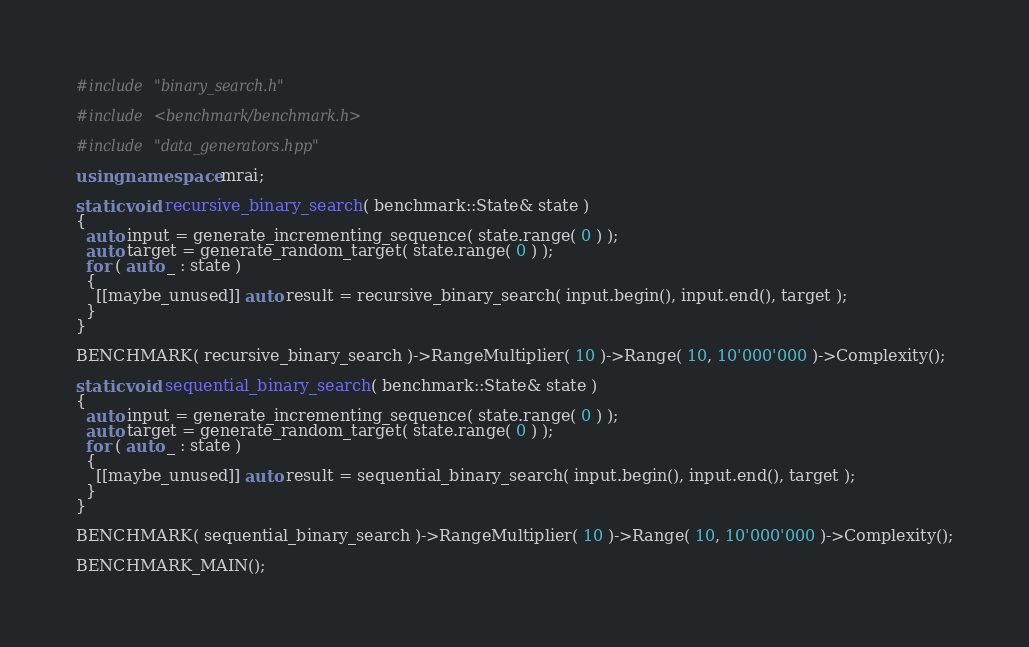<code> <loc_0><loc_0><loc_500><loc_500><_C++_>#include "binary_search.h"

#include <benchmark/benchmark.h>

#include "data_generators.hpp"

using namespace mrai;

static void recursive_binary_search( benchmark::State& state )
{
  auto input = generate_incrementing_sequence( state.range( 0 ) );
  auto target = generate_random_target( state.range( 0 ) );
  for ( auto _ : state )
  {
    [[maybe_unused]] auto result = recursive_binary_search( input.begin(), input.end(), target );
  }
}

BENCHMARK( recursive_binary_search )->RangeMultiplier( 10 )->Range( 10, 10'000'000 )->Complexity();

static void sequential_binary_search( benchmark::State& state )
{
  auto input = generate_incrementing_sequence( state.range( 0 ) );
  auto target = generate_random_target( state.range( 0 ) );
  for ( auto _ : state )
  {
    [[maybe_unused]] auto result = sequential_binary_search( input.begin(), input.end(), target );
  }
}

BENCHMARK( sequential_binary_search )->RangeMultiplier( 10 )->Range( 10, 10'000'000 )->Complexity();

BENCHMARK_MAIN();</code> 